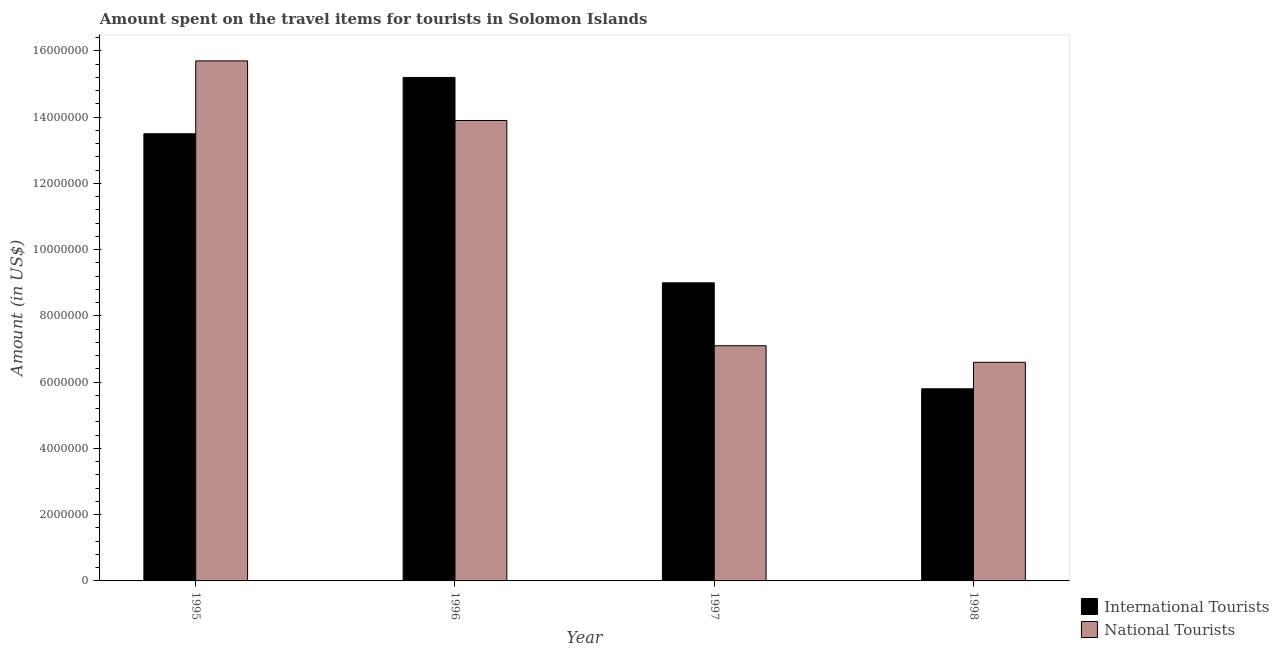Are the number of bars per tick equal to the number of legend labels?
Provide a succinct answer. Yes. Are the number of bars on each tick of the X-axis equal?
Ensure brevity in your answer.  Yes. What is the label of the 1st group of bars from the left?
Offer a terse response. 1995. What is the amount spent on travel items of national tourists in 1996?
Make the answer very short. 1.39e+07. Across all years, what is the maximum amount spent on travel items of national tourists?
Keep it short and to the point. 1.57e+07. Across all years, what is the minimum amount spent on travel items of national tourists?
Provide a succinct answer. 6.60e+06. In which year was the amount spent on travel items of national tourists minimum?
Ensure brevity in your answer.  1998. What is the total amount spent on travel items of national tourists in the graph?
Offer a very short reply. 4.33e+07. What is the difference between the amount spent on travel items of international tourists in 1996 and that in 1997?
Provide a short and direct response. 6.20e+06. What is the difference between the amount spent on travel items of international tourists in 1997 and the amount spent on travel items of national tourists in 1995?
Your answer should be compact. -4.50e+06. What is the average amount spent on travel items of national tourists per year?
Offer a terse response. 1.08e+07. What is the ratio of the amount spent on travel items of international tourists in 1995 to that in 1997?
Offer a terse response. 1.5. Is the amount spent on travel items of international tourists in 1995 less than that in 1997?
Offer a very short reply. No. What is the difference between the highest and the second highest amount spent on travel items of international tourists?
Offer a terse response. 1.70e+06. What is the difference between the highest and the lowest amount spent on travel items of national tourists?
Offer a terse response. 9.10e+06. In how many years, is the amount spent on travel items of national tourists greater than the average amount spent on travel items of national tourists taken over all years?
Your answer should be compact. 2. Is the sum of the amount spent on travel items of national tourists in 1996 and 1997 greater than the maximum amount spent on travel items of international tourists across all years?
Make the answer very short. Yes. What does the 2nd bar from the left in 1997 represents?
Make the answer very short. National Tourists. What does the 1st bar from the right in 1996 represents?
Make the answer very short. National Tourists. Are all the bars in the graph horizontal?
Your answer should be compact. No. Are the values on the major ticks of Y-axis written in scientific E-notation?
Your answer should be very brief. No. Does the graph contain any zero values?
Offer a very short reply. No. How many legend labels are there?
Offer a very short reply. 2. What is the title of the graph?
Offer a very short reply. Amount spent on the travel items for tourists in Solomon Islands. Does "Old" appear as one of the legend labels in the graph?
Offer a terse response. No. What is the label or title of the X-axis?
Provide a succinct answer. Year. What is the Amount (in US$) in International Tourists in 1995?
Make the answer very short. 1.35e+07. What is the Amount (in US$) of National Tourists in 1995?
Keep it short and to the point. 1.57e+07. What is the Amount (in US$) of International Tourists in 1996?
Your answer should be very brief. 1.52e+07. What is the Amount (in US$) of National Tourists in 1996?
Keep it short and to the point. 1.39e+07. What is the Amount (in US$) in International Tourists in 1997?
Ensure brevity in your answer.  9.00e+06. What is the Amount (in US$) in National Tourists in 1997?
Provide a succinct answer. 7.10e+06. What is the Amount (in US$) of International Tourists in 1998?
Offer a very short reply. 5.80e+06. What is the Amount (in US$) in National Tourists in 1998?
Give a very brief answer. 6.60e+06. Across all years, what is the maximum Amount (in US$) in International Tourists?
Your answer should be very brief. 1.52e+07. Across all years, what is the maximum Amount (in US$) in National Tourists?
Give a very brief answer. 1.57e+07. Across all years, what is the minimum Amount (in US$) in International Tourists?
Offer a terse response. 5.80e+06. Across all years, what is the minimum Amount (in US$) in National Tourists?
Your response must be concise. 6.60e+06. What is the total Amount (in US$) in International Tourists in the graph?
Your response must be concise. 4.35e+07. What is the total Amount (in US$) of National Tourists in the graph?
Keep it short and to the point. 4.33e+07. What is the difference between the Amount (in US$) of International Tourists in 1995 and that in 1996?
Ensure brevity in your answer.  -1.70e+06. What is the difference between the Amount (in US$) in National Tourists in 1995 and that in 1996?
Ensure brevity in your answer.  1.80e+06. What is the difference between the Amount (in US$) of International Tourists in 1995 and that in 1997?
Make the answer very short. 4.50e+06. What is the difference between the Amount (in US$) of National Tourists in 1995 and that in 1997?
Your answer should be compact. 8.60e+06. What is the difference between the Amount (in US$) in International Tourists in 1995 and that in 1998?
Ensure brevity in your answer.  7.70e+06. What is the difference between the Amount (in US$) in National Tourists in 1995 and that in 1998?
Your answer should be very brief. 9.10e+06. What is the difference between the Amount (in US$) of International Tourists in 1996 and that in 1997?
Give a very brief answer. 6.20e+06. What is the difference between the Amount (in US$) of National Tourists in 1996 and that in 1997?
Your answer should be compact. 6.80e+06. What is the difference between the Amount (in US$) of International Tourists in 1996 and that in 1998?
Make the answer very short. 9.40e+06. What is the difference between the Amount (in US$) in National Tourists in 1996 and that in 1998?
Your response must be concise. 7.30e+06. What is the difference between the Amount (in US$) in International Tourists in 1997 and that in 1998?
Your response must be concise. 3.20e+06. What is the difference between the Amount (in US$) of National Tourists in 1997 and that in 1998?
Your response must be concise. 5.00e+05. What is the difference between the Amount (in US$) of International Tourists in 1995 and the Amount (in US$) of National Tourists in 1996?
Provide a short and direct response. -4.00e+05. What is the difference between the Amount (in US$) in International Tourists in 1995 and the Amount (in US$) in National Tourists in 1997?
Keep it short and to the point. 6.40e+06. What is the difference between the Amount (in US$) of International Tourists in 1995 and the Amount (in US$) of National Tourists in 1998?
Your answer should be compact. 6.90e+06. What is the difference between the Amount (in US$) of International Tourists in 1996 and the Amount (in US$) of National Tourists in 1997?
Your response must be concise. 8.10e+06. What is the difference between the Amount (in US$) in International Tourists in 1996 and the Amount (in US$) in National Tourists in 1998?
Give a very brief answer. 8.60e+06. What is the difference between the Amount (in US$) in International Tourists in 1997 and the Amount (in US$) in National Tourists in 1998?
Give a very brief answer. 2.40e+06. What is the average Amount (in US$) of International Tourists per year?
Your answer should be very brief. 1.09e+07. What is the average Amount (in US$) in National Tourists per year?
Keep it short and to the point. 1.08e+07. In the year 1995, what is the difference between the Amount (in US$) in International Tourists and Amount (in US$) in National Tourists?
Your answer should be compact. -2.20e+06. In the year 1996, what is the difference between the Amount (in US$) of International Tourists and Amount (in US$) of National Tourists?
Keep it short and to the point. 1.30e+06. In the year 1997, what is the difference between the Amount (in US$) of International Tourists and Amount (in US$) of National Tourists?
Your answer should be very brief. 1.90e+06. In the year 1998, what is the difference between the Amount (in US$) of International Tourists and Amount (in US$) of National Tourists?
Offer a very short reply. -8.00e+05. What is the ratio of the Amount (in US$) in International Tourists in 1995 to that in 1996?
Keep it short and to the point. 0.89. What is the ratio of the Amount (in US$) in National Tourists in 1995 to that in 1996?
Your response must be concise. 1.13. What is the ratio of the Amount (in US$) in International Tourists in 1995 to that in 1997?
Make the answer very short. 1.5. What is the ratio of the Amount (in US$) of National Tourists in 1995 to that in 1997?
Your response must be concise. 2.21. What is the ratio of the Amount (in US$) in International Tourists in 1995 to that in 1998?
Ensure brevity in your answer.  2.33. What is the ratio of the Amount (in US$) of National Tourists in 1995 to that in 1998?
Ensure brevity in your answer.  2.38. What is the ratio of the Amount (in US$) in International Tourists in 1996 to that in 1997?
Your answer should be very brief. 1.69. What is the ratio of the Amount (in US$) in National Tourists in 1996 to that in 1997?
Your answer should be compact. 1.96. What is the ratio of the Amount (in US$) of International Tourists in 1996 to that in 1998?
Your answer should be compact. 2.62. What is the ratio of the Amount (in US$) in National Tourists in 1996 to that in 1998?
Provide a short and direct response. 2.11. What is the ratio of the Amount (in US$) of International Tourists in 1997 to that in 1998?
Provide a succinct answer. 1.55. What is the ratio of the Amount (in US$) of National Tourists in 1997 to that in 1998?
Your response must be concise. 1.08. What is the difference between the highest and the second highest Amount (in US$) of International Tourists?
Give a very brief answer. 1.70e+06. What is the difference between the highest and the second highest Amount (in US$) of National Tourists?
Offer a very short reply. 1.80e+06. What is the difference between the highest and the lowest Amount (in US$) in International Tourists?
Your response must be concise. 9.40e+06. What is the difference between the highest and the lowest Amount (in US$) of National Tourists?
Make the answer very short. 9.10e+06. 